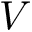Convert formula to latex. <formula><loc_0><loc_0><loc_500><loc_500>V</formula> 